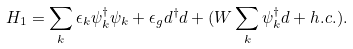<formula> <loc_0><loc_0><loc_500><loc_500>H _ { 1 } = \sum _ { k } \epsilon _ { k } \psi _ { k } ^ { \dagger } \psi _ { k } + \epsilon _ { g } d ^ { \dagger } d + ( W \sum _ { k } \psi _ { k } ^ { \dagger } d + h . c . ) .</formula> 